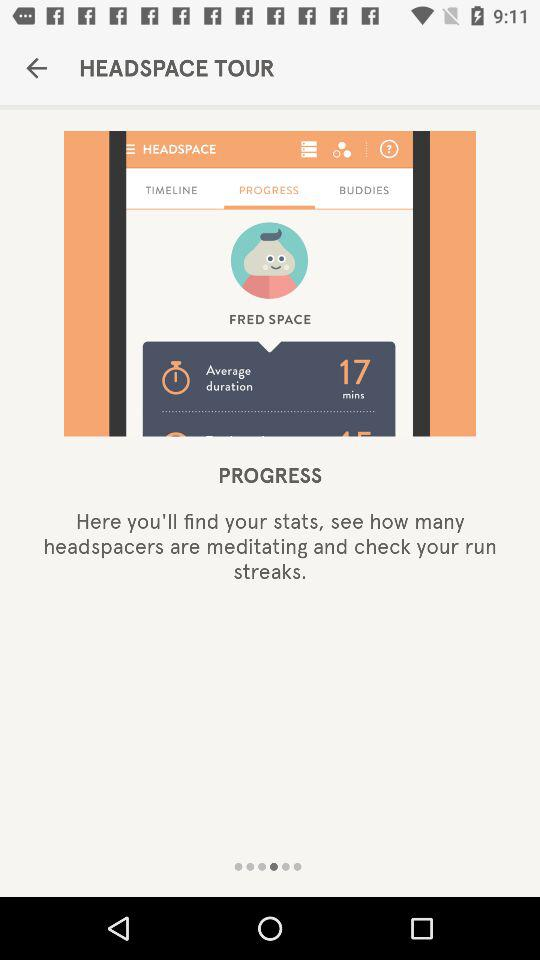What is the average duration? The average duration is 17 minutes. 